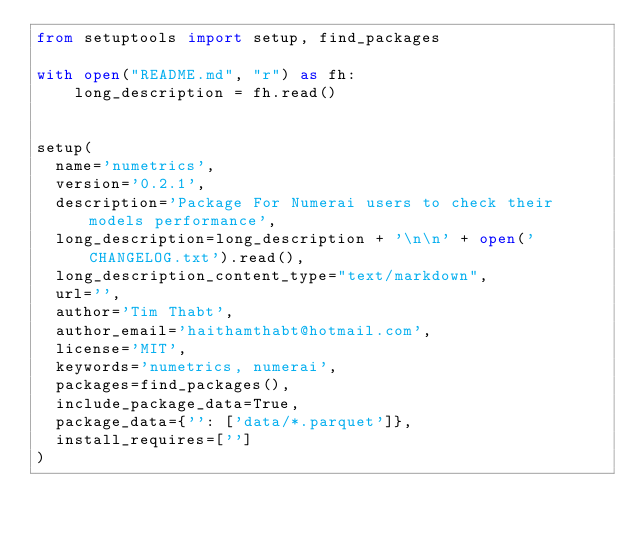<code> <loc_0><loc_0><loc_500><loc_500><_Python_>from setuptools import setup, find_packages

with open("README.md", "r") as fh:
    long_description = fh.read()
 
 
setup(
  name='numetrics',
  version='0.2.1',
  description='Package For Numerai users to check their models performance',
  long_description=long_description + '\n\n' + open('CHANGELOG.txt').read(),
  long_description_content_type="text/markdown",
  url='',  
  author='Tim Thabt',
  author_email='haithamthabt@hotmail.com',
  license='MIT', 
  keywords='numetrics, numerai', 
  packages=find_packages(),
  include_package_data=True,
  package_data={'': ['data/*.parquet']},
  install_requires=[''] 
)

</code> 